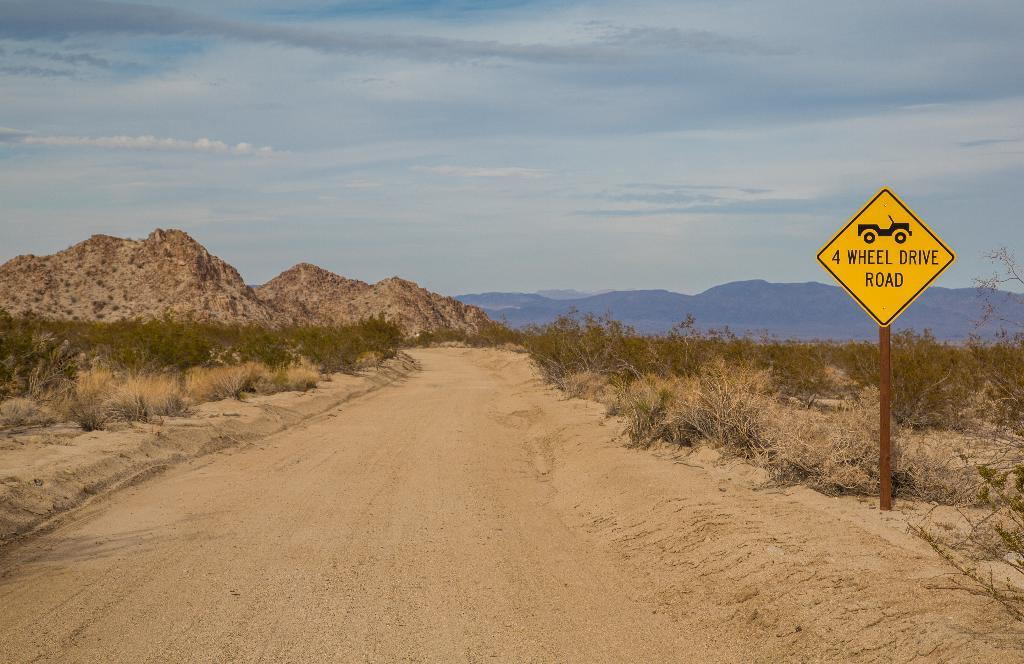<image>
Provide a brief description of the given image. A dirt road with mountains in the background and a yellow sign that says 4 wheel drive road. 